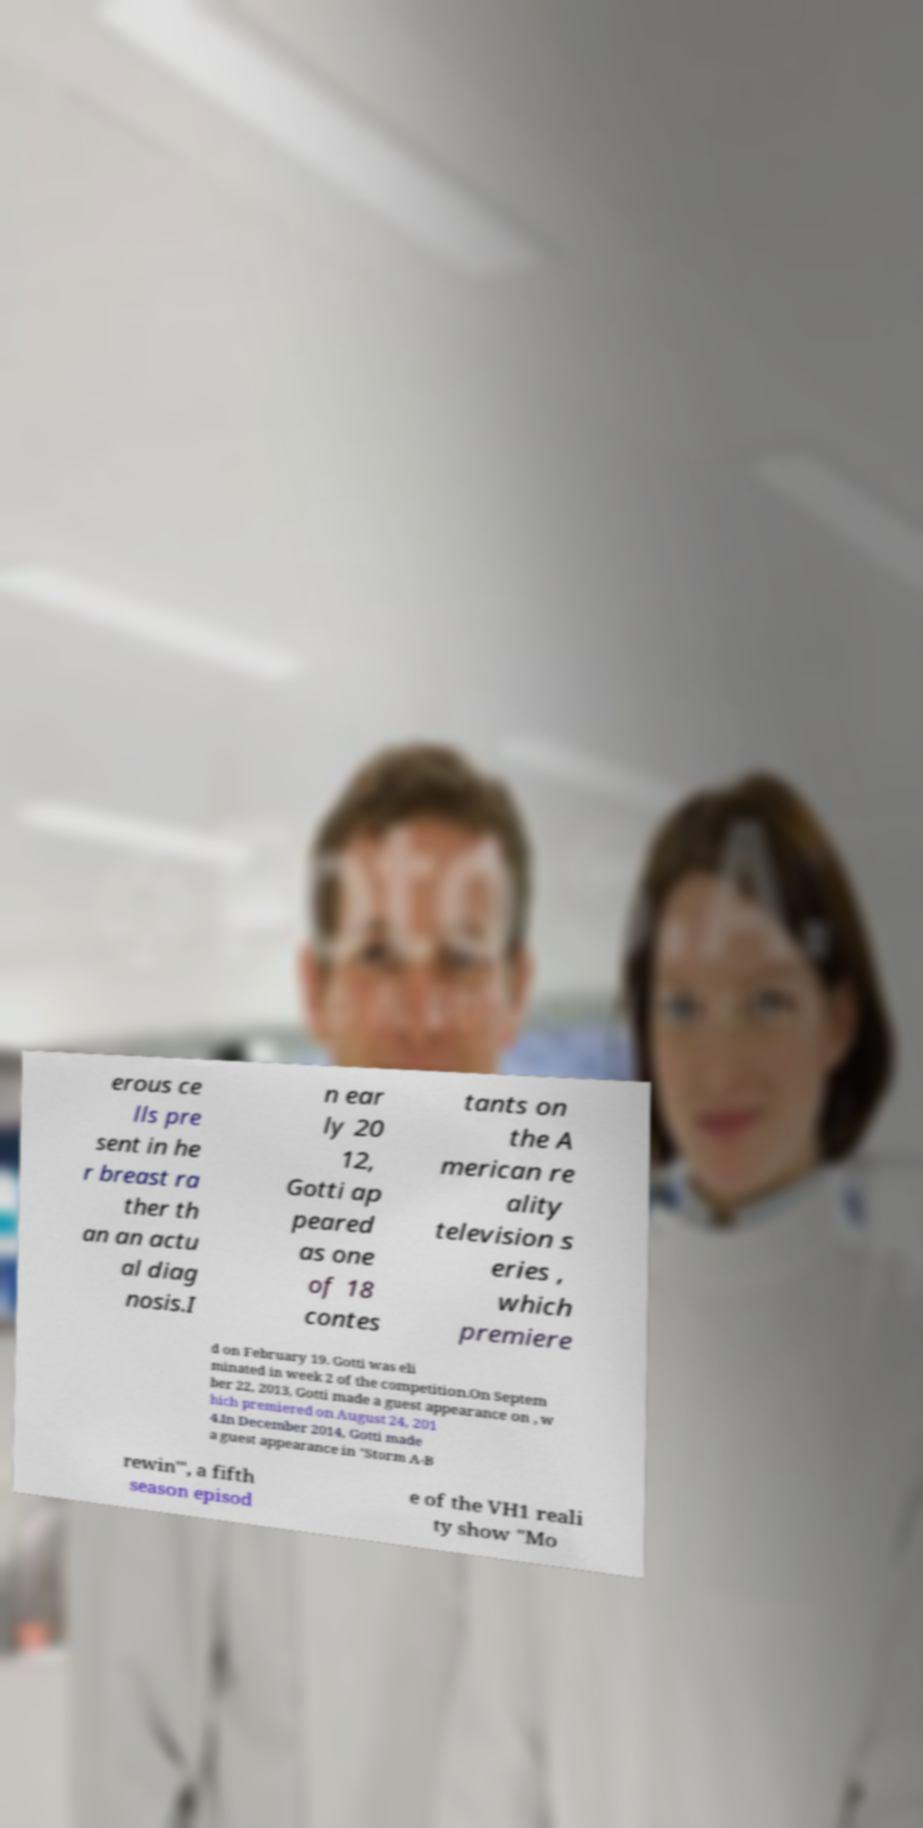What messages or text are displayed in this image? I need them in a readable, typed format. erous ce lls pre sent in he r breast ra ther th an an actu al diag nosis.I n ear ly 20 12, Gotti ap peared as one of 18 contes tants on the A merican re ality television s eries , which premiere d on February 19. Gotti was eli minated in week 2 of the competition.On Septem ber 22, 2013, Gotti made a guest appearance on , w hich premiered on August 24, 201 4.In December 2014, Gotti made a guest appearance in "Storm A-B rewin'", a fifth season episod e of the VH1 reali ty show "Mo 